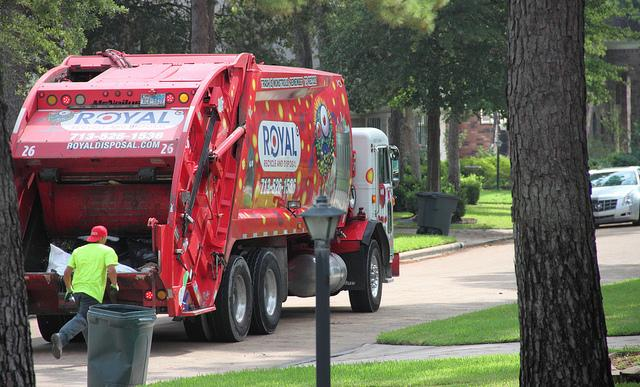What is being gathered by this vehicle? trash 